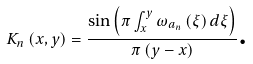Convert formula to latex. <formula><loc_0><loc_0><loc_500><loc_500>K _ { n } \left ( x , y \right ) = \frac { \sin \left ( \pi \int _ { x } ^ { y } \omega _ { a _ { n } } \left ( \xi \right ) d \xi \right ) } { \pi \left ( y - x \right ) } \text {.}</formula> 